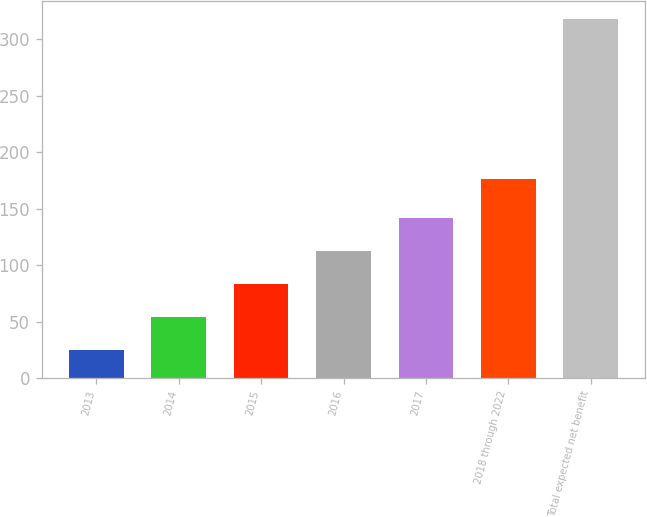<chart> <loc_0><loc_0><loc_500><loc_500><bar_chart><fcel>2013<fcel>2014<fcel>2015<fcel>2016<fcel>2017<fcel>2018 through 2022<fcel>Total expected net benefit<nl><fcel>25<fcel>54.3<fcel>83.6<fcel>112.9<fcel>142.2<fcel>176<fcel>318<nl></chart> 